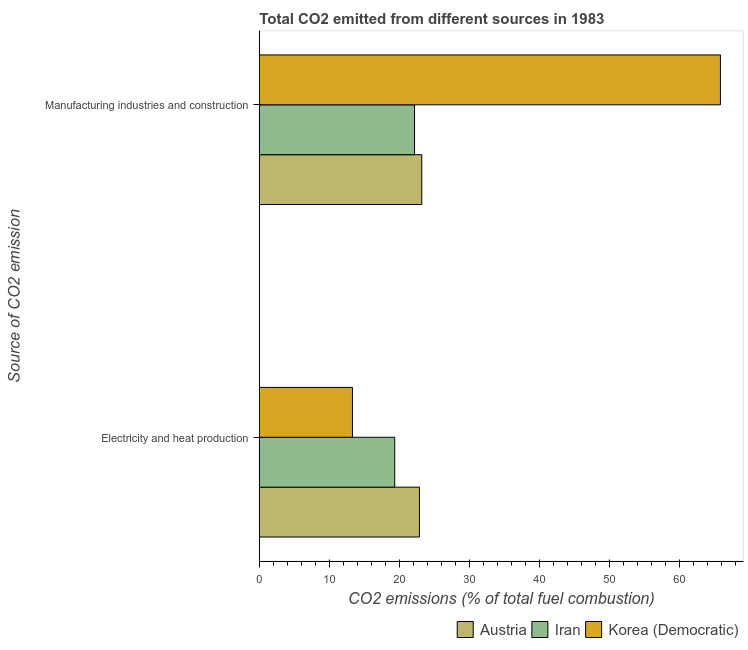How many groups of bars are there?
Your response must be concise. 2. How many bars are there on the 2nd tick from the top?
Provide a succinct answer. 3. What is the label of the 2nd group of bars from the top?
Provide a succinct answer. Electricity and heat production. What is the co2 emissions due to manufacturing industries in Austria?
Your answer should be very brief. 23.17. Across all countries, what is the maximum co2 emissions due to manufacturing industries?
Ensure brevity in your answer.  65.78. Across all countries, what is the minimum co2 emissions due to manufacturing industries?
Make the answer very short. 22.14. In which country was the co2 emissions due to electricity and heat production minimum?
Ensure brevity in your answer.  Korea (Democratic). What is the total co2 emissions due to electricity and heat production in the graph?
Offer a terse response. 55.44. What is the difference between the co2 emissions due to electricity and heat production in Korea (Democratic) and that in Austria?
Provide a short and direct response. -9.56. What is the difference between the co2 emissions due to manufacturing industries in Austria and the co2 emissions due to electricity and heat production in Iran?
Keep it short and to the point. 3.86. What is the average co2 emissions due to manufacturing industries per country?
Make the answer very short. 37.03. What is the difference between the co2 emissions due to electricity and heat production and co2 emissions due to manufacturing industries in Korea (Democratic)?
Offer a terse response. -52.5. In how many countries, is the co2 emissions due to manufacturing industries greater than 28 %?
Your response must be concise. 1. What is the ratio of the co2 emissions due to manufacturing industries in Austria to that in Iran?
Make the answer very short. 1.05. What does the 1st bar from the top in Manufacturing industries and construction represents?
Your response must be concise. Korea (Democratic). What does the 1st bar from the bottom in Electricity and heat production represents?
Offer a very short reply. Austria. How many bars are there?
Offer a very short reply. 6. Are all the bars in the graph horizontal?
Provide a short and direct response. Yes. What is the difference between two consecutive major ticks on the X-axis?
Your answer should be compact. 10. Are the values on the major ticks of X-axis written in scientific E-notation?
Give a very brief answer. No. Does the graph contain grids?
Make the answer very short. No. What is the title of the graph?
Offer a terse response. Total CO2 emitted from different sources in 1983. Does "Iran" appear as one of the legend labels in the graph?
Offer a terse response. Yes. What is the label or title of the X-axis?
Ensure brevity in your answer.  CO2 emissions (% of total fuel combustion). What is the label or title of the Y-axis?
Ensure brevity in your answer.  Source of CO2 emission. What is the CO2 emissions (% of total fuel combustion) of Austria in Electricity and heat production?
Offer a terse response. 22.84. What is the CO2 emissions (% of total fuel combustion) of Iran in Electricity and heat production?
Offer a very short reply. 19.32. What is the CO2 emissions (% of total fuel combustion) in Korea (Democratic) in Electricity and heat production?
Your response must be concise. 13.28. What is the CO2 emissions (% of total fuel combustion) of Austria in Manufacturing industries and construction?
Keep it short and to the point. 23.17. What is the CO2 emissions (% of total fuel combustion) of Iran in Manufacturing industries and construction?
Your response must be concise. 22.14. What is the CO2 emissions (% of total fuel combustion) in Korea (Democratic) in Manufacturing industries and construction?
Offer a terse response. 65.78. Across all Source of CO2 emission, what is the maximum CO2 emissions (% of total fuel combustion) of Austria?
Keep it short and to the point. 23.17. Across all Source of CO2 emission, what is the maximum CO2 emissions (% of total fuel combustion) in Iran?
Give a very brief answer. 22.14. Across all Source of CO2 emission, what is the maximum CO2 emissions (% of total fuel combustion) in Korea (Democratic)?
Offer a very short reply. 65.78. Across all Source of CO2 emission, what is the minimum CO2 emissions (% of total fuel combustion) of Austria?
Offer a terse response. 22.84. Across all Source of CO2 emission, what is the minimum CO2 emissions (% of total fuel combustion) of Iran?
Your answer should be compact. 19.32. Across all Source of CO2 emission, what is the minimum CO2 emissions (% of total fuel combustion) in Korea (Democratic)?
Provide a short and direct response. 13.28. What is the total CO2 emissions (% of total fuel combustion) of Austria in the graph?
Give a very brief answer. 46.02. What is the total CO2 emissions (% of total fuel combustion) of Iran in the graph?
Your response must be concise. 41.46. What is the total CO2 emissions (% of total fuel combustion) in Korea (Democratic) in the graph?
Make the answer very short. 79.06. What is the difference between the CO2 emissions (% of total fuel combustion) in Austria in Electricity and heat production and that in Manufacturing industries and construction?
Your answer should be compact. -0.33. What is the difference between the CO2 emissions (% of total fuel combustion) of Iran in Electricity and heat production and that in Manufacturing industries and construction?
Make the answer very short. -2.83. What is the difference between the CO2 emissions (% of total fuel combustion) in Korea (Democratic) in Electricity and heat production and that in Manufacturing industries and construction?
Offer a terse response. -52.5. What is the difference between the CO2 emissions (% of total fuel combustion) of Austria in Electricity and heat production and the CO2 emissions (% of total fuel combustion) of Iran in Manufacturing industries and construction?
Your answer should be compact. 0.7. What is the difference between the CO2 emissions (% of total fuel combustion) of Austria in Electricity and heat production and the CO2 emissions (% of total fuel combustion) of Korea (Democratic) in Manufacturing industries and construction?
Ensure brevity in your answer.  -42.94. What is the difference between the CO2 emissions (% of total fuel combustion) of Iran in Electricity and heat production and the CO2 emissions (% of total fuel combustion) of Korea (Democratic) in Manufacturing industries and construction?
Provide a succinct answer. -46.47. What is the average CO2 emissions (% of total fuel combustion) in Austria per Source of CO2 emission?
Provide a short and direct response. 23.01. What is the average CO2 emissions (% of total fuel combustion) in Iran per Source of CO2 emission?
Your answer should be very brief. 20.73. What is the average CO2 emissions (% of total fuel combustion) in Korea (Democratic) per Source of CO2 emission?
Keep it short and to the point. 39.53. What is the difference between the CO2 emissions (% of total fuel combustion) of Austria and CO2 emissions (% of total fuel combustion) of Iran in Electricity and heat production?
Provide a succinct answer. 3.53. What is the difference between the CO2 emissions (% of total fuel combustion) in Austria and CO2 emissions (% of total fuel combustion) in Korea (Democratic) in Electricity and heat production?
Your answer should be compact. 9.56. What is the difference between the CO2 emissions (% of total fuel combustion) of Iran and CO2 emissions (% of total fuel combustion) of Korea (Democratic) in Electricity and heat production?
Offer a very short reply. 6.03. What is the difference between the CO2 emissions (% of total fuel combustion) in Austria and CO2 emissions (% of total fuel combustion) in Iran in Manufacturing industries and construction?
Give a very brief answer. 1.03. What is the difference between the CO2 emissions (% of total fuel combustion) of Austria and CO2 emissions (% of total fuel combustion) of Korea (Democratic) in Manufacturing industries and construction?
Your answer should be very brief. -42.61. What is the difference between the CO2 emissions (% of total fuel combustion) of Iran and CO2 emissions (% of total fuel combustion) of Korea (Democratic) in Manufacturing industries and construction?
Offer a very short reply. -43.64. What is the ratio of the CO2 emissions (% of total fuel combustion) in Austria in Electricity and heat production to that in Manufacturing industries and construction?
Provide a short and direct response. 0.99. What is the ratio of the CO2 emissions (% of total fuel combustion) of Iran in Electricity and heat production to that in Manufacturing industries and construction?
Your answer should be compact. 0.87. What is the ratio of the CO2 emissions (% of total fuel combustion) of Korea (Democratic) in Electricity and heat production to that in Manufacturing industries and construction?
Your answer should be compact. 0.2. What is the difference between the highest and the second highest CO2 emissions (% of total fuel combustion) of Austria?
Ensure brevity in your answer.  0.33. What is the difference between the highest and the second highest CO2 emissions (% of total fuel combustion) of Iran?
Your answer should be very brief. 2.83. What is the difference between the highest and the second highest CO2 emissions (% of total fuel combustion) in Korea (Democratic)?
Provide a succinct answer. 52.5. What is the difference between the highest and the lowest CO2 emissions (% of total fuel combustion) in Austria?
Offer a very short reply. 0.33. What is the difference between the highest and the lowest CO2 emissions (% of total fuel combustion) in Iran?
Your answer should be compact. 2.83. What is the difference between the highest and the lowest CO2 emissions (% of total fuel combustion) in Korea (Democratic)?
Make the answer very short. 52.5. 